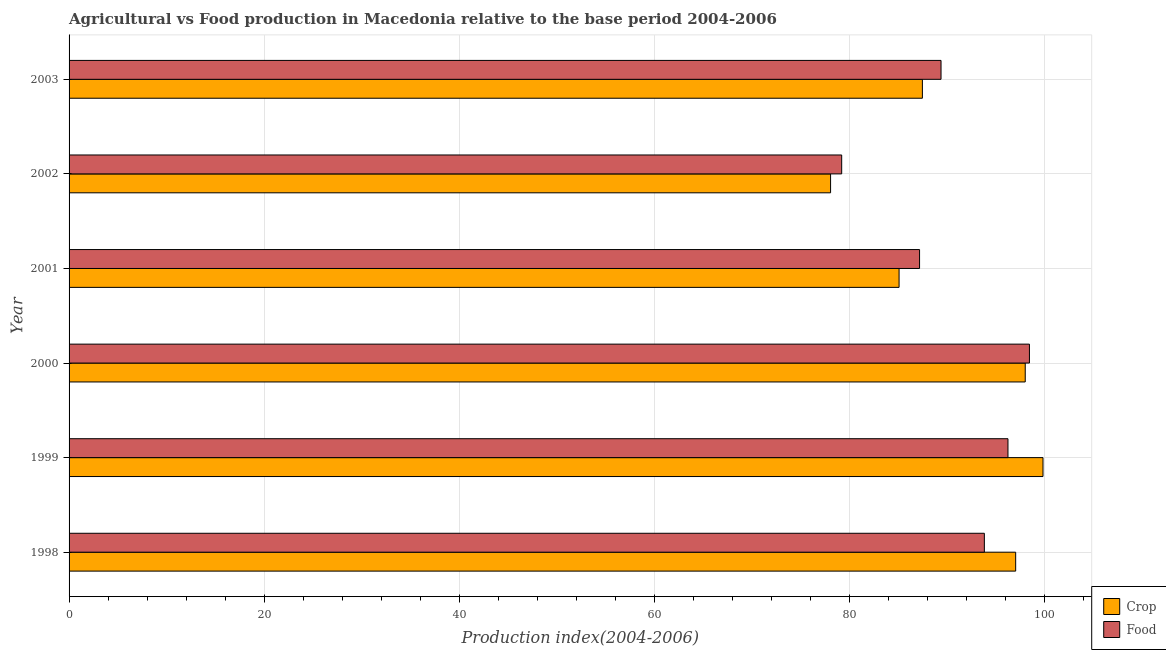Are the number of bars on each tick of the Y-axis equal?
Provide a short and direct response. Yes. How many bars are there on the 1st tick from the bottom?
Your answer should be compact. 2. What is the label of the 5th group of bars from the top?
Your answer should be very brief. 1999. In how many cases, is the number of bars for a given year not equal to the number of legend labels?
Offer a terse response. 0. What is the crop production index in 2002?
Give a very brief answer. 78.04. Across all years, what is the maximum food production index?
Keep it short and to the point. 98.42. Across all years, what is the minimum food production index?
Offer a very short reply. 79.18. In which year was the food production index maximum?
Your response must be concise. 2000. What is the total food production index in the graph?
Give a very brief answer. 544.14. What is the difference between the crop production index in 2001 and that in 2002?
Make the answer very short. 7.02. What is the difference between the food production index in 2003 and the crop production index in 2001?
Provide a succinct answer. 4.3. What is the average crop production index per year?
Provide a succinct answer. 90.89. In the year 1999, what is the difference between the food production index and crop production index?
Give a very brief answer. -3.59. What is the ratio of the food production index in 1998 to that in 2002?
Offer a terse response. 1.19. Is the food production index in 1998 less than that in 1999?
Give a very brief answer. Yes. What is the difference between the highest and the second highest crop production index?
Ensure brevity in your answer.  1.82. What is the difference between the highest and the lowest crop production index?
Offer a very short reply. 21.77. In how many years, is the crop production index greater than the average crop production index taken over all years?
Your response must be concise. 3. What does the 2nd bar from the top in 2002 represents?
Provide a succinct answer. Crop. What does the 2nd bar from the bottom in 1998 represents?
Give a very brief answer. Food. How many bars are there?
Keep it short and to the point. 12. Are all the bars in the graph horizontal?
Your response must be concise. Yes. Are the values on the major ticks of X-axis written in scientific E-notation?
Provide a short and direct response. No. Does the graph contain any zero values?
Your answer should be compact. No. Where does the legend appear in the graph?
Provide a short and direct response. Bottom right. What is the title of the graph?
Your response must be concise. Agricultural vs Food production in Macedonia relative to the base period 2004-2006. What is the label or title of the X-axis?
Provide a succinct answer. Production index(2004-2006). What is the label or title of the Y-axis?
Give a very brief answer. Year. What is the Production index(2004-2006) in Crop in 1998?
Offer a very short reply. 97.01. What is the Production index(2004-2006) in Food in 1998?
Keep it short and to the point. 93.8. What is the Production index(2004-2006) in Crop in 1999?
Your response must be concise. 99.81. What is the Production index(2004-2006) of Food in 1999?
Keep it short and to the point. 96.22. What is the Production index(2004-2006) in Crop in 2000?
Offer a very short reply. 97.99. What is the Production index(2004-2006) in Food in 2000?
Provide a succinct answer. 98.42. What is the Production index(2004-2006) in Crop in 2001?
Keep it short and to the point. 85.06. What is the Production index(2004-2006) of Food in 2001?
Offer a very short reply. 87.16. What is the Production index(2004-2006) in Crop in 2002?
Your response must be concise. 78.04. What is the Production index(2004-2006) in Food in 2002?
Offer a terse response. 79.18. What is the Production index(2004-2006) of Crop in 2003?
Give a very brief answer. 87.45. What is the Production index(2004-2006) of Food in 2003?
Your response must be concise. 89.36. Across all years, what is the maximum Production index(2004-2006) in Crop?
Offer a terse response. 99.81. Across all years, what is the maximum Production index(2004-2006) in Food?
Your answer should be very brief. 98.42. Across all years, what is the minimum Production index(2004-2006) of Crop?
Your response must be concise. 78.04. Across all years, what is the minimum Production index(2004-2006) of Food?
Offer a terse response. 79.18. What is the total Production index(2004-2006) of Crop in the graph?
Keep it short and to the point. 545.36. What is the total Production index(2004-2006) in Food in the graph?
Provide a succinct answer. 544.14. What is the difference between the Production index(2004-2006) of Food in 1998 and that in 1999?
Make the answer very short. -2.42. What is the difference between the Production index(2004-2006) in Crop in 1998 and that in 2000?
Your answer should be very brief. -0.98. What is the difference between the Production index(2004-2006) in Food in 1998 and that in 2000?
Give a very brief answer. -4.62. What is the difference between the Production index(2004-2006) in Crop in 1998 and that in 2001?
Offer a very short reply. 11.95. What is the difference between the Production index(2004-2006) in Food in 1998 and that in 2001?
Provide a succinct answer. 6.64. What is the difference between the Production index(2004-2006) in Crop in 1998 and that in 2002?
Provide a succinct answer. 18.97. What is the difference between the Production index(2004-2006) in Food in 1998 and that in 2002?
Your answer should be very brief. 14.62. What is the difference between the Production index(2004-2006) in Crop in 1998 and that in 2003?
Keep it short and to the point. 9.56. What is the difference between the Production index(2004-2006) of Food in 1998 and that in 2003?
Make the answer very short. 4.44. What is the difference between the Production index(2004-2006) of Crop in 1999 and that in 2000?
Your answer should be compact. 1.82. What is the difference between the Production index(2004-2006) of Food in 1999 and that in 2000?
Offer a very short reply. -2.2. What is the difference between the Production index(2004-2006) in Crop in 1999 and that in 2001?
Provide a short and direct response. 14.75. What is the difference between the Production index(2004-2006) in Food in 1999 and that in 2001?
Your answer should be very brief. 9.06. What is the difference between the Production index(2004-2006) of Crop in 1999 and that in 2002?
Your answer should be very brief. 21.77. What is the difference between the Production index(2004-2006) in Food in 1999 and that in 2002?
Make the answer very short. 17.04. What is the difference between the Production index(2004-2006) of Crop in 1999 and that in 2003?
Ensure brevity in your answer.  12.36. What is the difference between the Production index(2004-2006) in Food in 1999 and that in 2003?
Your answer should be very brief. 6.86. What is the difference between the Production index(2004-2006) in Crop in 2000 and that in 2001?
Offer a terse response. 12.93. What is the difference between the Production index(2004-2006) of Food in 2000 and that in 2001?
Provide a succinct answer. 11.26. What is the difference between the Production index(2004-2006) in Crop in 2000 and that in 2002?
Make the answer very short. 19.95. What is the difference between the Production index(2004-2006) in Food in 2000 and that in 2002?
Keep it short and to the point. 19.24. What is the difference between the Production index(2004-2006) in Crop in 2000 and that in 2003?
Give a very brief answer. 10.54. What is the difference between the Production index(2004-2006) in Food in 2000 and that in 2003?
Your answer should be very brief. 9.06. What is the difference between the Production index(2004-2006) of Crop in 2001 and that in 2002?
Provide a succinct answer. 7.02. What is the difference between the Production index(2004-2006) in Food in 2001 and that in 2002?
Your answer should be very brief. 7.98. What is the difference between the Production index(2004-2006) in Crop in 2001 and that in 2003?
Give a very brief answer. -2.39. What is the difference between the Production index(2004-2006) in Crop in 2002 and that in 2003?
Give a very brief answer. -9.41. What is the difference between the Production index(2004-2006) in Food in 2002 and that in 2003?
Give a very brief answer. -10.18. What is the difference between the Production index(2004-2006) in Crop in 1998 and the Production index(2004-2006) in Food in 1999?
Make the answer very short. 0.79. What is the difference between the Production index(2004-2006) in Crop in 1998 and the Production index(2004-2006) in Food in 2000?
Your answer should be very brief. -1.41. What is the difference between the Production index(2004-2006) of Crop in 1998 and the Production index(2004-2006) of Food in 2001?
Offer a terse response. 9.85. What is the difference between the Production index(2004-2006) of Crop in 1998 and the Production index(2004-2006) of Food in 2002?
Offer a very short reply. 17.83. What is the difference between the Production index(2004-2006) in Crop in 1998 and the Production index(2004-2006) in Food in 2003?
Your response must be concise. 7.65. What is the difference between the Production index(2004-2006) of Crop in 1999 and the Production index(2004-2006) of Food in 2000?
Your answer should be compact. 1.39. What is the difference between the Production index(2004-2006) of Crop in 1999 and the Production index(2004-2006) of Food in 2001?
Your answer should be compact. 12.65. What is the difference between the Production index(2004-2006) of Crop in 1999 and the Production index(2004-2006) of Food in 2002?
Your answer should be very brief. 20.63. What is the difference between the Production index(2004-2006) in Crop in 1999 and the Production index(2004-2006) in Food in 2003?
Give a very brief answer. 10.45. What is the difference between the Production index(2004-2006) in Crop in 2000 and the Production index(2004-2006) in Food in 2001?
Keep it short and to the point. 10.83. What is the difference between the Production index(2004-2006) of Crop in 2000 and the Production index(2004-2006) of Food in 2002?
Offer a terse response. 18.81. What is the difference between the Production index(2004-2006) in Crop in 2000 and the Production index(2004-2006) in Food in 2003?
Provide a short and direct response. 8.63. What is the difference between the Production index(2004-2006) in Crop in 2001 and the Production index(2004-2006) in Food in 2002?
Provide a succinct answer. 5.88. What is the difference between the Production index(2004-2006) of Crop in 2002 and the Production index(2004-2006) of Food in 2003?
Provide a succinct answer. -11.32. What is the average Production index(2004-2006) in Crop per year?
Offer a terse response. 90.89. What is the average Production index(2004-2006) of Food per year?
Offer a very short reply. 90.69. In the year 1998, what is the difference between the Production index(2004-2006) in Crop and Production index(2004-2006) in Food?
Your answer should be very brief. 3.21. In the year 1999, what is the difference between the Production index(2004-2006) of Crop and Production index(2004-2006) of Food?
Provide a short and direct response. 3.59. In the year 2000, what is the difference between the Production index(2004-2006) of Crop and Production index(2004-2006) of Food?
Provide a short and direct response. -0.43. In the year 2002, what is the difference between the Production index(2004-2006) in Crop and Production index(2004-2006) in Food?
Offer a terse response. -1.14. In the year 2003, what is the difference between the Production index(2004-2006) of Crop and Production index(2004-2006) of Food?
Keep it short and to the point. -1.91. What is the ratio of the Production index(2004-2006) of Crop in 1998 to that in 1999?
Keep it short and to the point. 0.97. What is the ratio of the Production index(2004-2006) in Food in 1998 to that in 1999?
Your answer should be compact. 0.97. What is the ratio of the Production index(2004-2006) in Crop in 1998 to that in 2000?
Your response must be concise. 0.99. What is the ratio of the Production index(2004-2006) of Food in 1998 to that in 2000?
Your response must be concise. 0.95. What is the ratio of the Production index(2004-2006) of Crop in 1998 to that in 2001?
Give a very brief answer. 1.14. What is the ratio of the Production index(2004-2006) in Food in 1998 to that in 2001?
Your response must be concise. 1.08. What is the ratio of the Production index(2004-2006) of Crop in 1998 to that in 2002?
Keep it short and to the point. 1.24. What is the ratio of the Production index(2004-2006) of Food in 1998 to that in 2002?
Give a very brief answer. 1.18. What is the ratio of the Production index(2004-2006) of Crop in 1998 to that in 2003?
Ensure brevity in your answer.  1.11. What is the ratio of the Production index(2004-2006) in Food in 1998 to that in 2003?
Keep it short and to the point. 1.05. What is the ratio of the Production index(2004-2006) in Crop in 1999 to that in 2000?
Make the answer very short. 1.02. What is the ratio of the Production index(2004-2006) in Food in 1999 to that in 2000?
Your answer should be compact. 0.98. What is the ratio of the Production index(2004-2006) of Crop in 1999 to that in 2001?
Offer a terse response. 1.17. What is the ratio of the Production index(2004-2006) of Food in 1999 to that in 2001?
Your answer should be compact. 1.1. What is the ratio of the Production index(2004-2006) in Crop in 1999 to that in 2002?
Your answer should be very brief. 1.28. What is the ratio of the Production index(2004-2006) in Food in 1999 to that in 2002?
Make the answer very short. 1.22. What is the ratio of the Production index(2004-2006) of Crop in 1999 to that in 2003?
Keep it short and to the point. 1.14. What is the ratio of the Production index(2004-2006) of Food in 1999 to that in 2003?
Keep it short and to the point. 1.08. What is the ratio of the Production index(2004-2006) of Crop in 2000 to that in 2001?
Give a very brief answer. 1.15. What is the ratio of the Production index(2004-2006) of Food in 2000 to that in 2001?
Offer a terse response. 1.13. What is the ratio of the Production index(2004-2006) of Crop in 2000 to that in 2002?
Ensure brevity in your answer.  1.26. What is the ratio of the Production index(2004-2006) of Food in 2000 to that in 2002?
Your response must be concise. 1.24. What is the ratio of the Production index(2004-2006) in Crop in 2000 to that in 2003?
Your response must be concise. 1.12. What is the ratio of the Production index(2004-2006) of Food in 2000 to that in 2003?
Ensure brevity in your answer.  1.1. What is the ratio of the Production index(2004-2006) in Crop in 2001 to that in 2002?
Make the answer very short. 1.09. What is the ratio of the Production index(2004-2006) in Food in 2001 to that in 2002?
Your response must be concise. 1.1. What is the ratio of the Production index(2004-2006) of Crop in 2001 to that in 2003?
Offer a very short reply. 0.97. What is the ratio of the Production index(2004-2006) of Food in 2001 to that in 2003?
Your response must be concise. 0.98. What is the ratio of the Production index(2004-2006) in Crop in 2002 to that in 2003?
Your response must be concise. 0.89. What is the ratio of the Production index(2004-2006) of Food in 2002 to that in 2003?
Offer a very short reply. 0.89. What is the difference between the highest and the second highest Production index(2004-2006) in Crop?
Your answer should be very brief. 1.82. What is the difference between the highest and the second highest Production index(2004-2006) in Food?
Ensure brevity in your answer.  2.2. What is the difference between the highest and the lowest Production index(2004-2006) of Crop?
Your response must be concise. 21.77. What is the difference between the highest and the lowest Production index(2004-2006) of Food?
Provide a short and direct response. 19.24. 